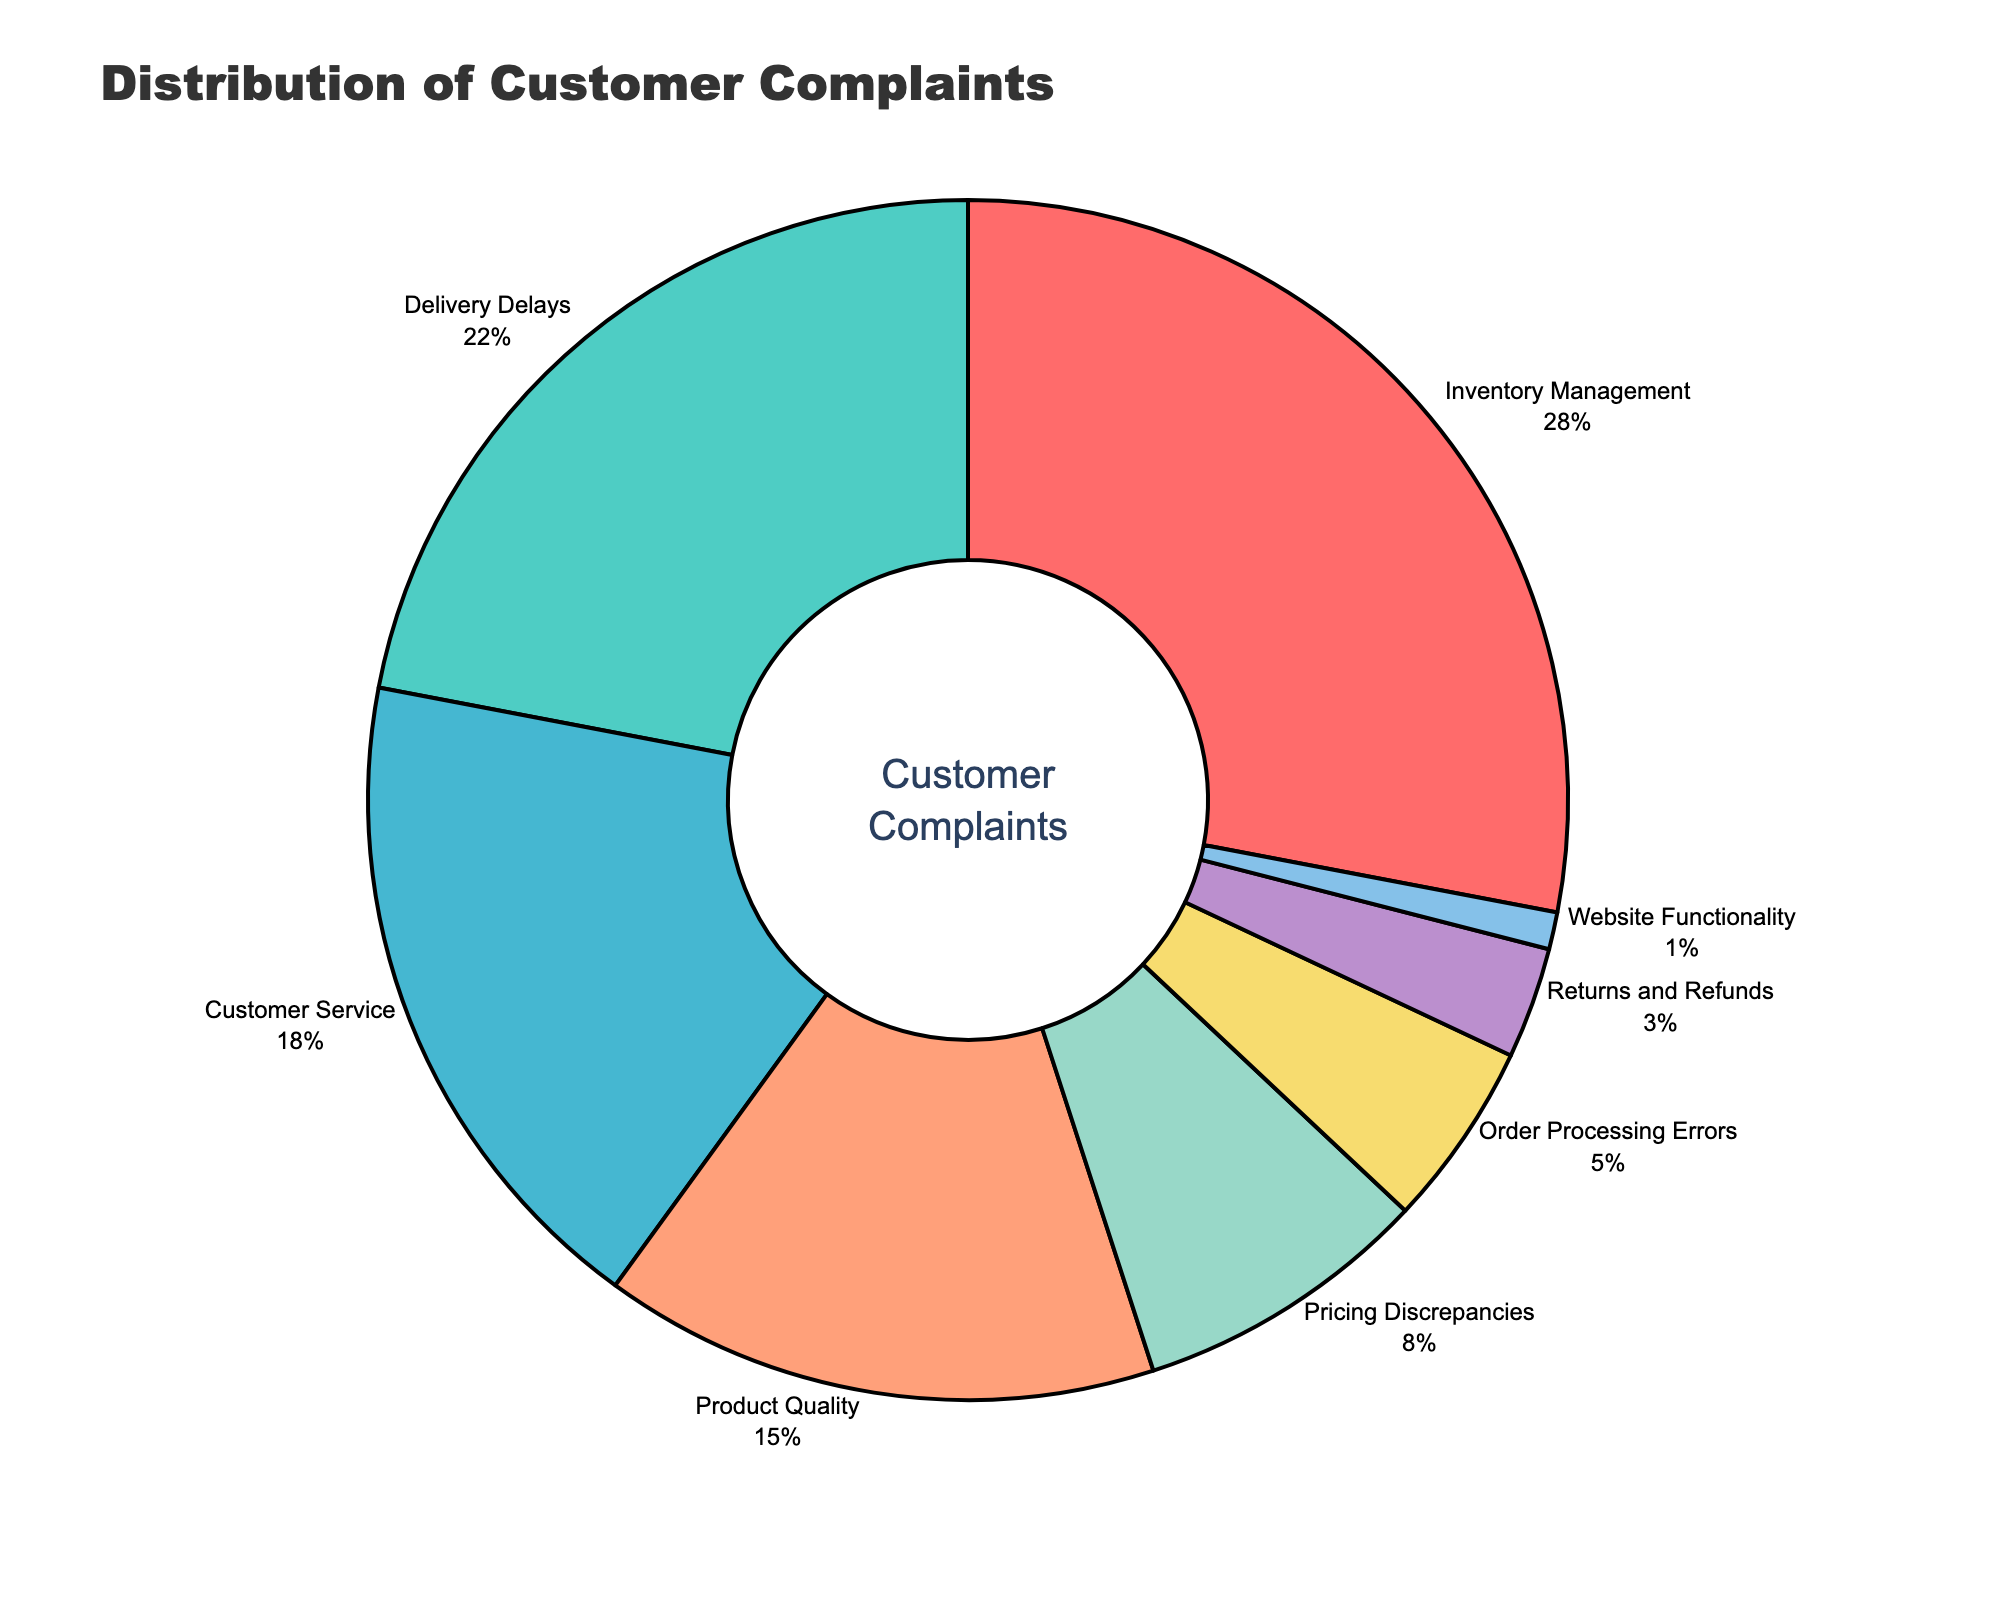What's the largest category of customer complaints? The figure shows varying percentages of customer complaints by category. The largest slice of the donut chart represents the category with the highest percentage. The "Inventory Management" category occupies the largest portion at 28%.
Answer: Inventory Management Which category has more complaints: Product Quality or Delivery Delays? To compare the two categories, look at their respective portions of the donut chart. "Delivery Delays" is 22% while "Product Quality" is 15%. Therefore, Delivery Delays has more complaints than Product Quality.
Answer: Delivery Delays What's the combined percentage of complaints for Customer Service and Order Processing Errors? Add the percentages for the two categories: Customer Service (18%) and Order Processing Errors (5%). The sum is 18% + 5% = 23%.
Answer: 23% What is the difference in complaint percentage between Pricing Discrepancies and Returns and Refunds? Subtract the percentage for Returns and Refunds (3%) from the percentage for Pricing Discrepancies (8%). The difference is 8% - 3% = 5%.
Answer: 5% Which category has the fewest complaints? The smallest portion of the donut chart represents the category with the fewest complaints. "Website Functionality" has the smallest slice at 1%.
Answer: Website Functionality Is the percentage of complaints for Inventory Management more than double that of Pricing Discrepancies? Compare double the percentage of Pricing Discrepancies (8% x 2 = 16%) with Inventory Management (28%). Since 28% is greater than 16%, Inventory Management has more than double the complaints compared to Pricing Discrepancies.
Answer: Yes How many categories have a percentage of complaints greater than 10%? Identify and count the categories with more than 10% complaints: Inventory Management (28%), Delivery Delays (22%), Customer Service (18%), and Product Quality (15%). There are 4 categories.
Answer: 4 If we combine the top three complaint categories, what is their combined percentage? Sum the percentages of the top three categories: Inventory Management (28%), Delivery Delays (22%), and Customer Service (18%). The total is 28% + 22% + 18% = 68%.
Answer: 68% What color represents Order Processing Errors in the chart? The colors in the donut chart are linked to specific categories. Order Processing Errors are represented by a color close to yellow.
Answer: Yellow If another category called "Technical Support" is added with 6%, will it have more complaints than Website Functionality? Compare the new category percentage (6%) with Website Functionality (1%). Since 6% is greater than 1%, Technical Support would have more complaints than Website Functionality.
Answer: Yes 